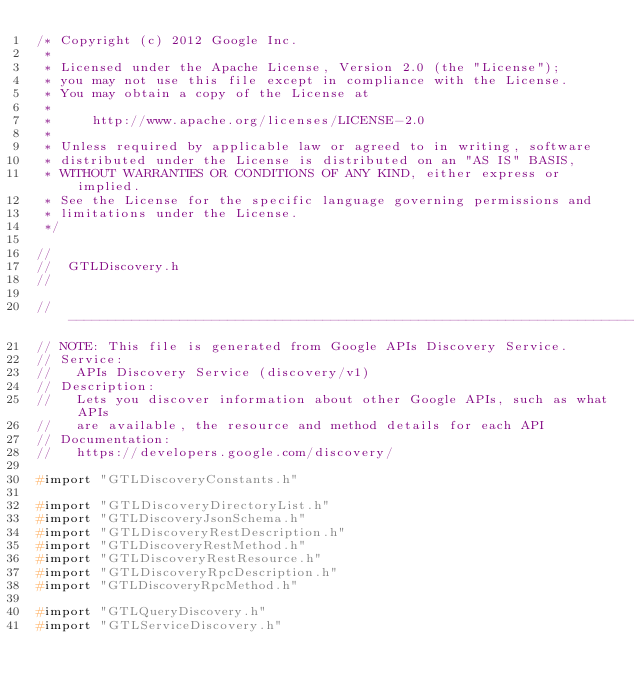<code> <loc_0><loc_0><loc_500><loc_500><_C_>/* Copyright (c) 2012 Google Inc.
 *
 * Licensed under the Apache License, Version 2.0 (the "License");
 * you may not use this file except in compliance with the License.
 * You may obtain a copy of the License at
 *
 *     http://www.apache.org/licenses/LICENSE-2.0
 *
 * Unless required by applicable law or agreed to in writing, software
 * distributed under the License is distributed on an "AS IS" BASIS,
 * WITHOUT WARRANTIES OR CONDITIONS OF ANY KIND, either express or implied.
 * See the License for the specific language governing permissions and
 * limitations under the License.
 */

//
//  GTLDiscovery.h
//

// ----------------------------------------------------------------------------
// NOTE: This file is generated from Google APIs Discovery Service.
// Service:
//   APIs Discovery Service (discovery/v1)
// Description:
//   Lets you discover information about other Google APIs, such as what APIs
//   are available, the resource and method details for each API
// Documentation:
//   https://developers.google.com/discovery/

#import "GTLDiscoveryConstants.h"

#import "GTLDiscoveryDirectoryList.h"
#import "GTLDiscoveryJsonSchema.h"
#import "GTLDiscoveryRestDescription.h"
#import "GTLDiscoveryRestMethod.h"
#import "GTLDiscoveryRestResource.h"
#import "GTLDiscoveryRpcDescription.h"
#import "GTLDiscoveryRpcMethod.h"

#import "GTLQueryDiscovery.h"
#import "GTLServiceDiscovery.h"
</code> 